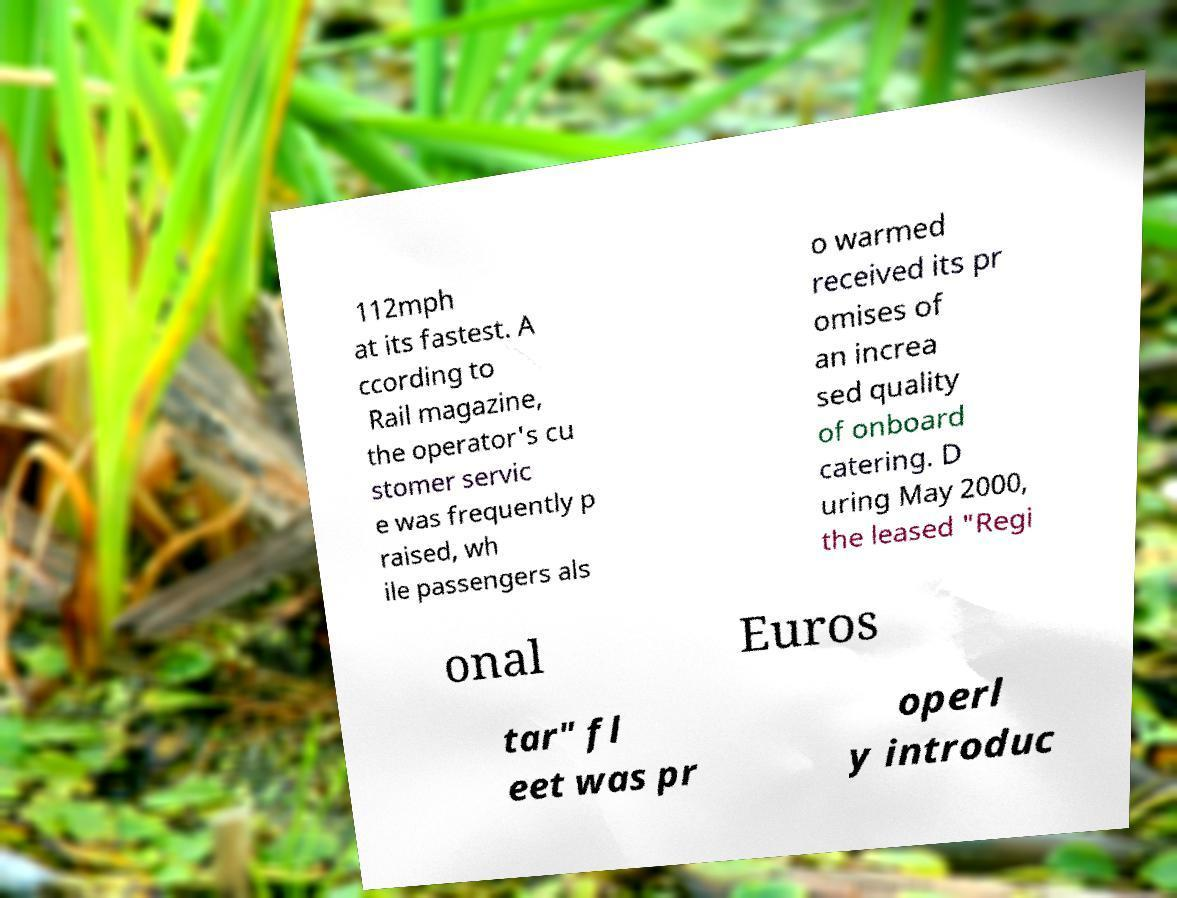Can you read and provide the text displayed in the image?This photo seems to have some interesting text. Can you extract and type it out for me? 112mph at its fastest. A ccording to Rail magazine, the operator's cu stomer servic e was frequently p raised, wh ile passengers als o warmed received its pr omises of an increa sed quality of onboard catering. D uring May 2000, the leased "Regi onal Euros tar" fl eet was pr operl y introduc 